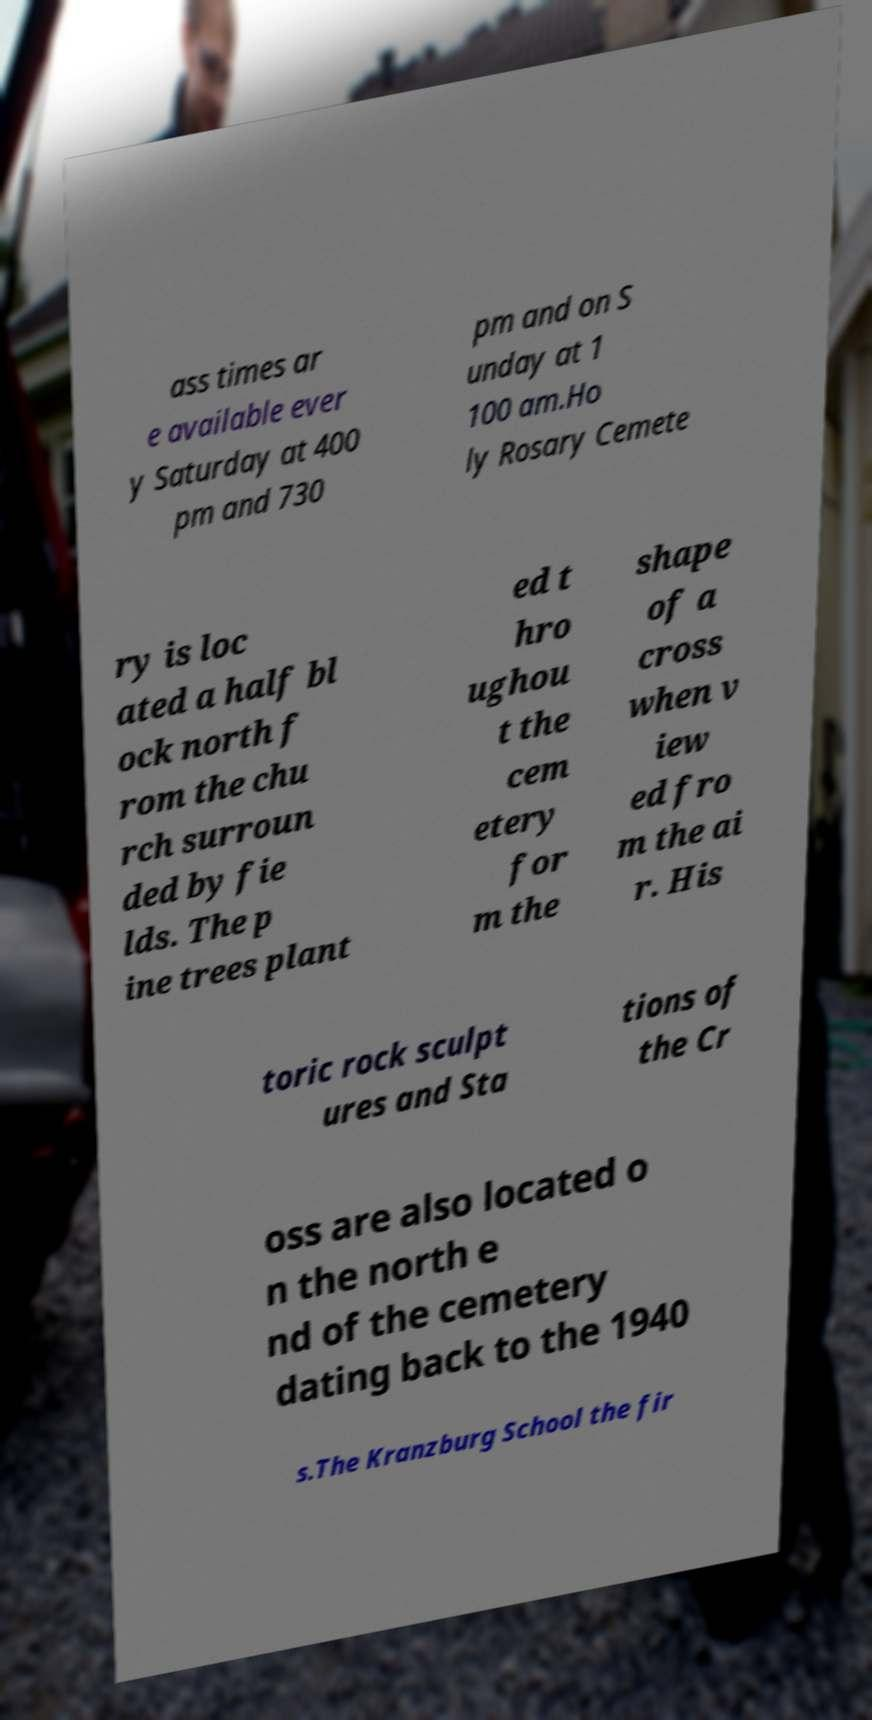Could you extract and type out the text from this image? ass times ar e available ever y Saturday at 400 pm and 730 pm and on S unday at 1 100 am.Ho ly Rosary Cemete ry is loc ated a half bl ock north f rom the chu rch surroun ded by fie lds. The p ine trees plant ed t hro ughou t the cem etery for m the shape of a cross when v iew ed fro m the ai r. His toric rock sculpt ures and Sta tions of the Cr oss are also located o n the north e nd of the cemetery dating back to the 1940 s.The Kranzburg School the fir 